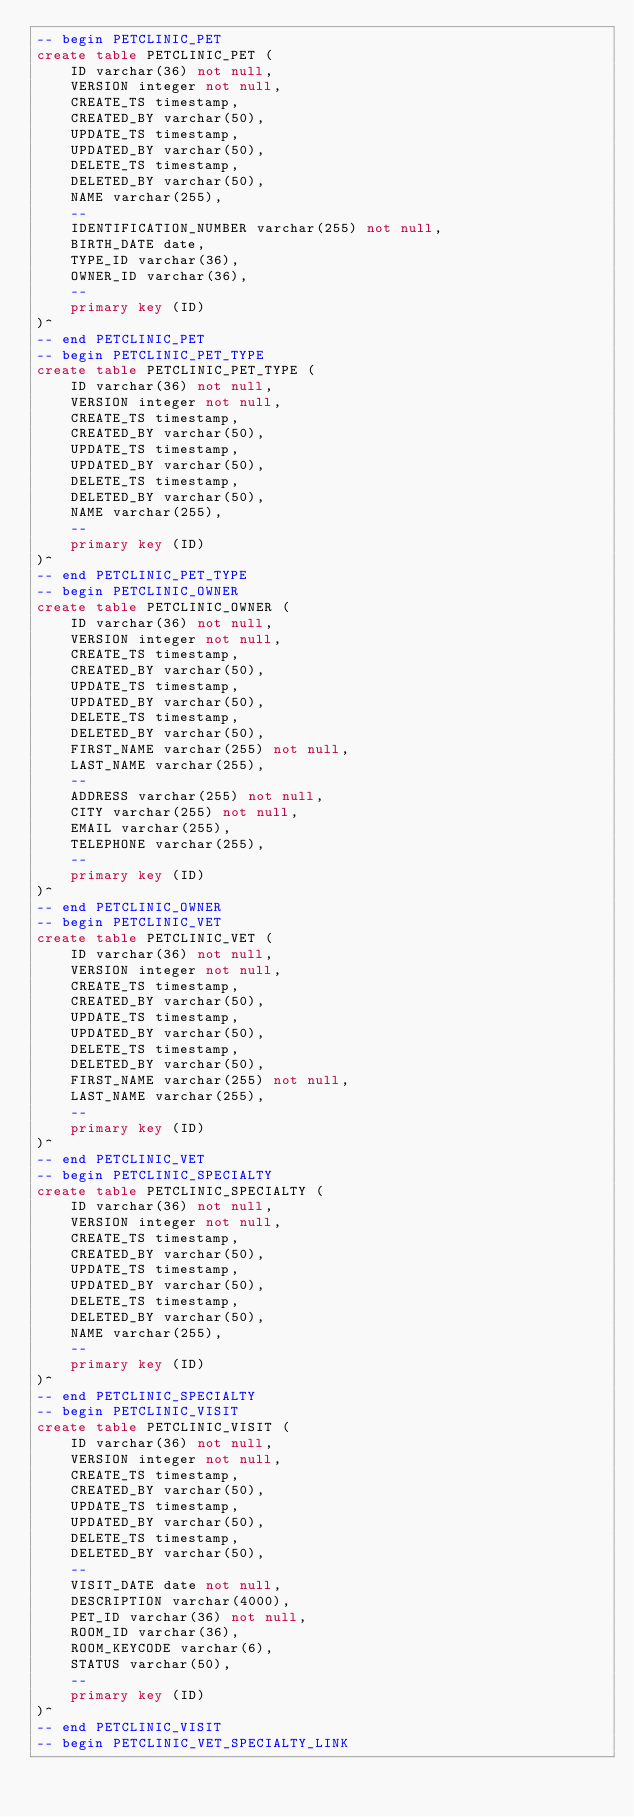<code> <loc_0><loc_0><loc_500><loc_500><_SQL_>-- begin PETCLINIC_PET
create table PETCLINIC_PET (
    ID varchar(36) not null,
    VERSION integer not null,
    CREATE_TS timestamp,
    CREATED_BY varchar(50),
    UPDATE_TS timestamp,
    UPDATED_BY varchar(50),
    DELETE_TS timestamp,
    DELETED_BY varchar(50),
    NAME varchar(255),
    --
    IDENTIFICATION_NUMBER varchar(255) not null,
    BIRTH_DATE date,
    TYPE_ID varchar(36),
    OWNER_ID varchar(36),
    --
    primary key (ID)
)^
-- end PETCLINIC_PET
-- begin PETCLINIC_PET_TYPE
create table PETCLINIC_PET_TYPE (
    ID varchar(36) not null,
    VERSION integer not null,
    CREATE_TS timestamp,
    CREATED_BY varchar(50),
    UPDATE_TS timestamp,
    UPDATED_BY varchar(50),
    DELETE_TS timestamp,
    DELETED_BY varchar(50),
    NAME varchar(255),
    --
    primary key (ID)
)^
-- end PETCLINIC_PET_TYPE
-- begin PETCLINIC_OWNER
create table PETCLINIC_OWNER (
    ID varchar(36) not null,
    VERSION integer not null,
    CREATE_TS timestamp,
    CREATED_BY varchar(50),
    UPDATE_TS timestamp,
    UPDATED_BY varchar(50),
    DELETE_TS timestamp,
    DELETED_BY varchar(50),
    FIRST_NAME varchar(255) not null,
    LAST_NAME varchar(255),
    --
    ADDRESS varchar(255) not null,
    CITY varchar(255) not null,
    EMAIL varchar(255),
    TELEPHONE varchar(255),
    --
    primary key (ID)
)^
-- end PETCLINIC_OWNER
-- begin PETCLINIC_VET
create table PETCLINIC_VET (
    ID varchar(36) not null,
    VERSION integer not null,
    CREATE_TS timestamp,
    CREATED_BY varchar(50),
    UPDATE_TS timestamp,
    UPDATED_BY varchar(50),
    DELETE_TS timestamp,
    DELETED_BY varchar(50),
    FIRST_NAME varchar(255) not null,
    LAST_NAME varchar(255),
    --
    primary key (ID)
)^
-- end PETCLINIC_VET
-- begin PETCLINIC_SPECIALTY
create table PETCLINIC_SPECIALTY (
    ID varchar(36) not null,
    VERSION integer not null,
    CREATE_TS timestamp,
    CREATED_BY varchar(50),
    UPDATE_TS timestamp,
    UPDATED_BY varchar(50),
    DELETE_TS timestamp,
    DELETED_BY varchar(50),
    NAME varchar(255),
    --
    primary key (ID)
)^
-- end PETCLINIC_SPECIALTY
-- begin PETCLINIC_VISIT
create table PETCLINIC_VISIT (
    ID varchar(36) not null,
    VERSION integer not null,
    CREATE_TS timestamp,
    CREATED_BY varchar(50),
    UPDATE_TS timestamp,
    UPDATED_BY varchar(50),
    DELETE_TS timestamp,
    DELETED_BY varchar(50),
    --
    VISIT_DATE date not null,
    DESCRIPTION varchar(4000),
    PET_ID varchar(36) not null,
    ROOM_ID varchar(36),
    ROOM_KEYCODE varchar(6),
    STATUS varchar(50),
    --
    primary key (ID)
)^
-- end PETCLINIC_VISIT
-- begin PETCLINIC_VET_SPECIALTY_LINK</code> 